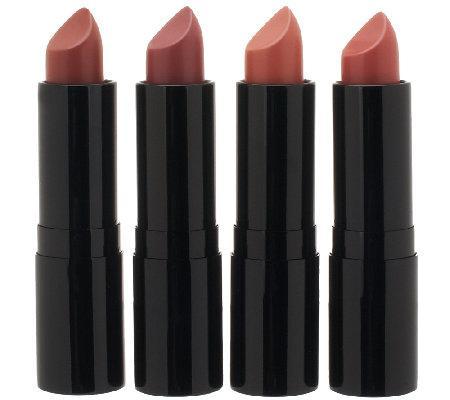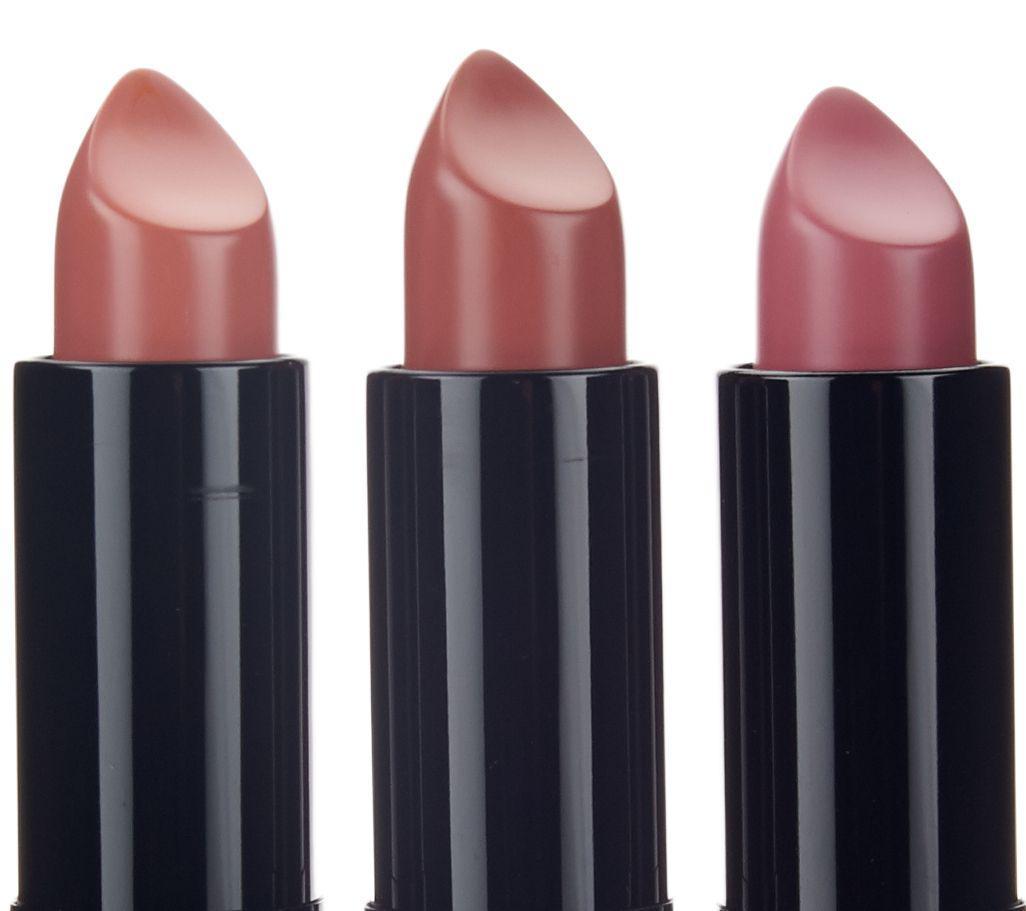The first image is the image on the left, the second image is the image on the right. Assess this claim about the two images: "There are more lipsticks on the right than on the left image.". Correct or not? Answer yes or no. No. The first image is the image on the left, the second image is the image on the right. Assess this claim about the two images: "One image shows exactly five available shades of lipstick.". Correct or not? Answer yes or no. No. The first image is the image on the left, the second image is the image on the right. Assess this claim about the two images: "There are exactly three lip makeups in the image on the right.". Correct or not? Answer yes or no. Yes. The first image is the image on the left, the second image is the image on the right. Evaluate the accuracy of this statement regarding the images: "There is one closed tube of lipstick in line with all of the open tubes of lipstick.". Is it true? Answer yes or no. No. 